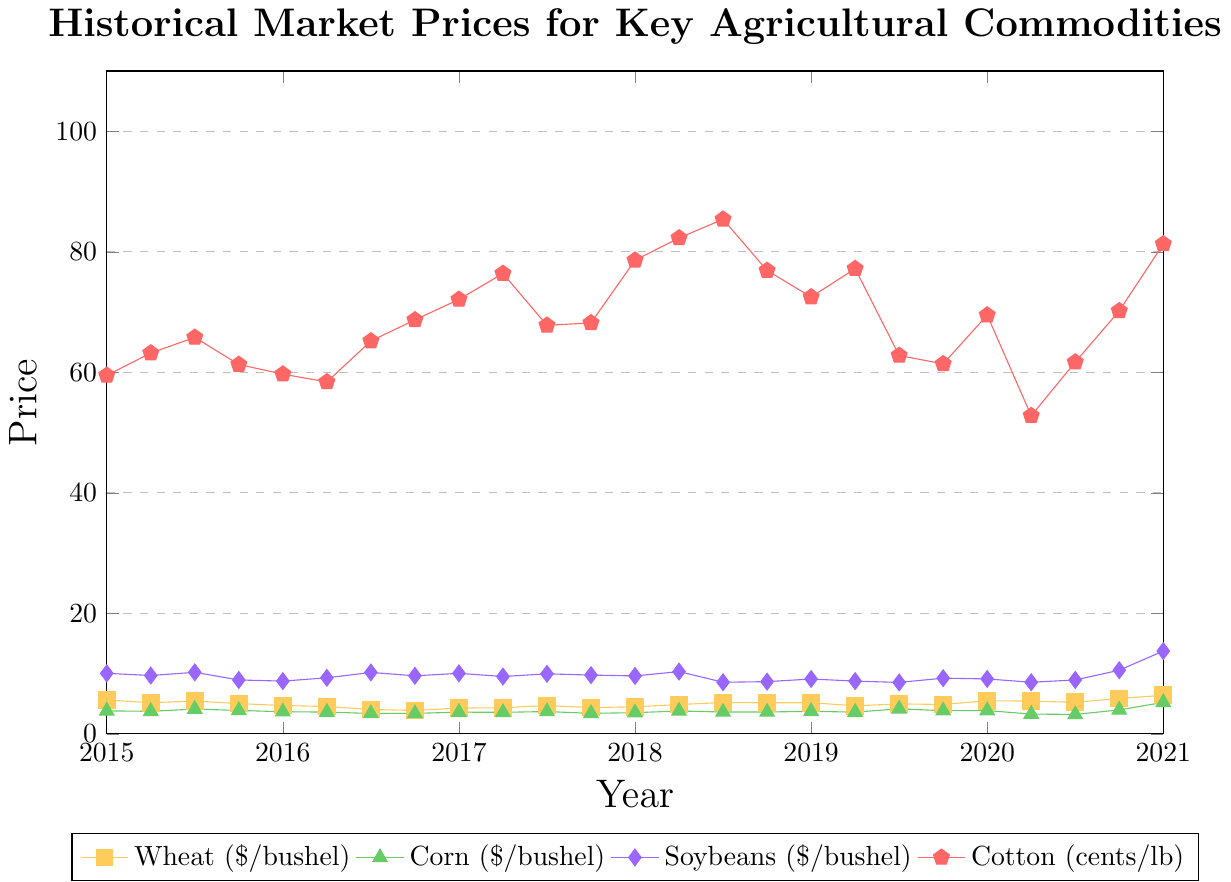What year did wheat prices first drop below $5 per bushel? In the figure, we see that wheat prices fell below $5 per bushel for the first time in the year 2016. The plot shows the wheat prices dip below the threshold line starting around this period.
Answer: 2016 During which year did corn prices exhibit the highest increase within the year? By observing the corn price trend, the largest increase within a single year occurs in 2021, where prices increased dramatically from around $5.23 in January to $6.75 in July.
Answer: 2021 Which commodity had the highest price and in which year and month? The plot shows that cotton had the highest price, recorded in October 2021, reaching 108.2 cents per pound.
Answer: Cotton, Oct 2021 In which year did soybeans first exceed $10 per bushel again after 2015? We see from the plot that after soybeans exceeded $10 in 2015, they next exceeded $10 per bushel again in the year 2020 in October.
Answer: 2020 When examining wheat and corn prices, which one had more fluctuation from 2015 to 2021? The corn prices show more significant changes and higher fluctuation compared to wheat prices over the years. Corn ranges from roughly $3.23 to $6.75, while wheat's fluctuations are somewhat more stable from around $3.89 to $7.64.
Answer: Corn What was the average price of cotton in 2018? By inspecting the plot, the cotton prices for 2018 are approximately 78.6 (Jan), 82.3 (Apr), 85.4 (Jul), and 76.9 (Oct). The average is calculated as:
\[
\text{Average} = \frac{78.6 + 82.3 + 85.4 + 76.9}{4} = 80.8
\]
Answer: 80.8 Was there any commodity that reached its peak price in 2021? Which was it and what was the price? The plot indicates that a high peak for Soybeans was achieved in April 2021 at $15.36 per bushel. Additionally, cotton reached its peak in October 2021 at 108.2 cents per pound.
Answer: Soybeans, Cotton How did the price of all commodities change from January 2020 to January 2021? Wheat increased from around $5.50 to $6.41, Corn from approximately $3.87 to $5.23, Soybeans from roughly $9.12 to $13.75, and Cotton from around 69.5 to 81.3 cents per pound. Therefore, all commodities experienced a considerable rise during this period.
Answer: All increased Comparing the peak prices, which commodity exhibited the steepest price rise from its lowest point to its highest point? Cotton shows the most substantial increase from its low of around 52.8 cents in April 2020 to its peak at 108.2 cents in October 2021, more than doubling in price.
Answer: Cotton 